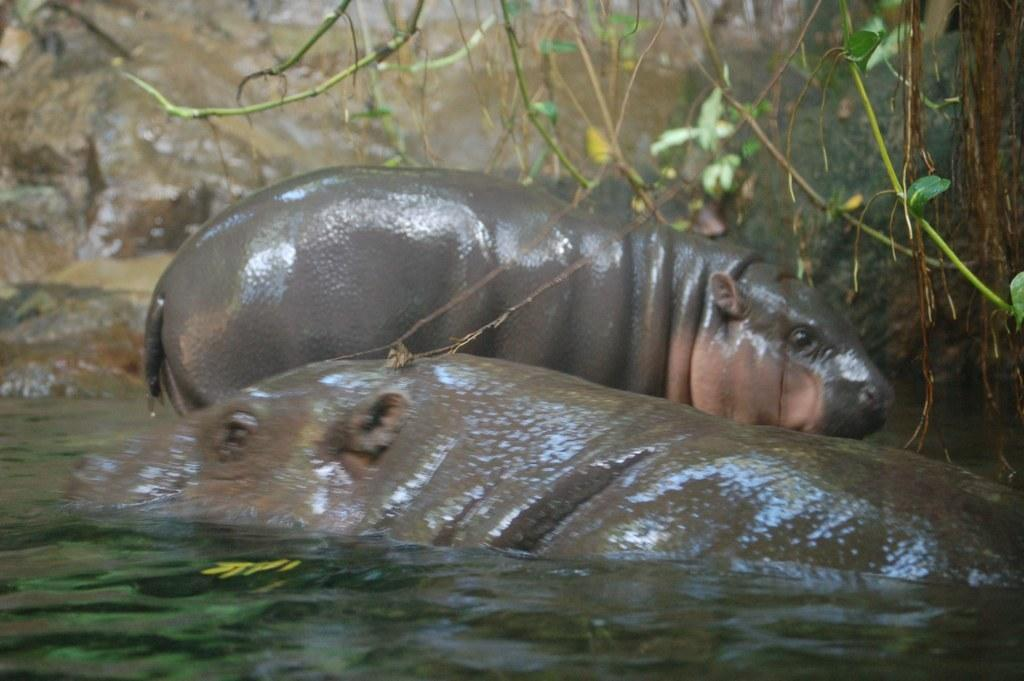What is the primary element visible in the image? There is water in the image. What other living organisms can be seen in the image? There are animals in the image. What type of vegetation is visible in the background of the image? There are plants in the background of the image. What type of expert advice can be found in the image? There is no expert advice present in the image; it features water, animals, and plants. What experience can be gained from observing the image? The image itself does not provide an experience, but observing it may lead to a better understanding of the relationship between water, animals, and plants. 